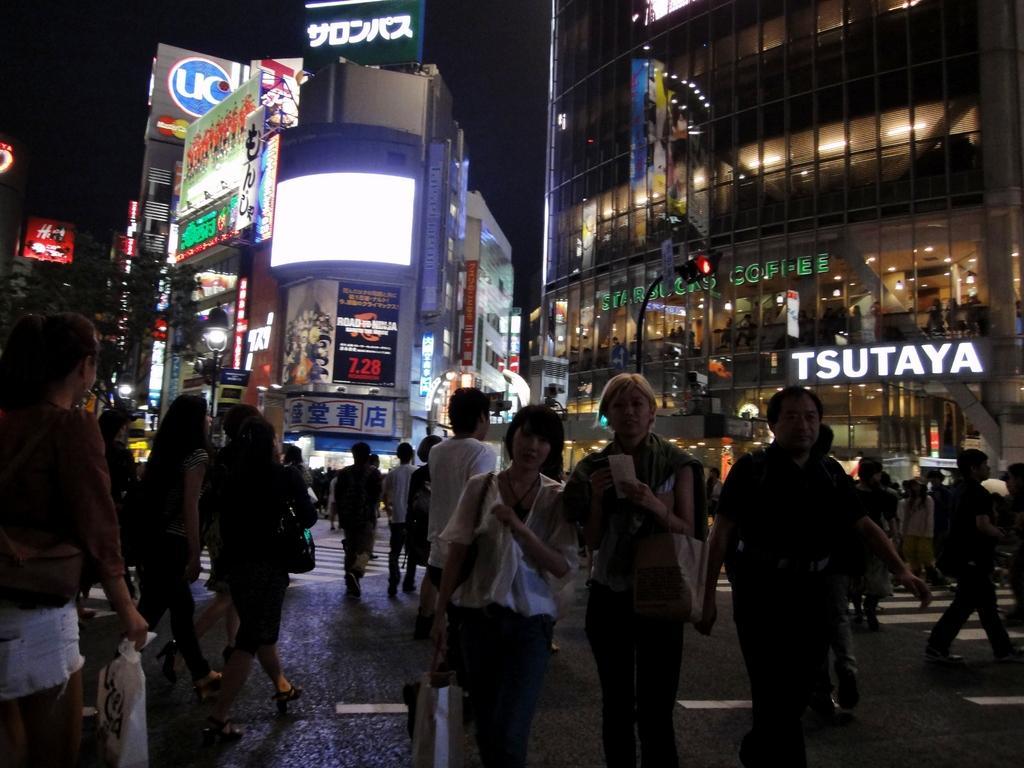Describe this image in one or two sentences. The picture is taken on a road. There are many people walking on the road. In the background there are buildings. In the buildings there are shops. Here there is traffic signal. 